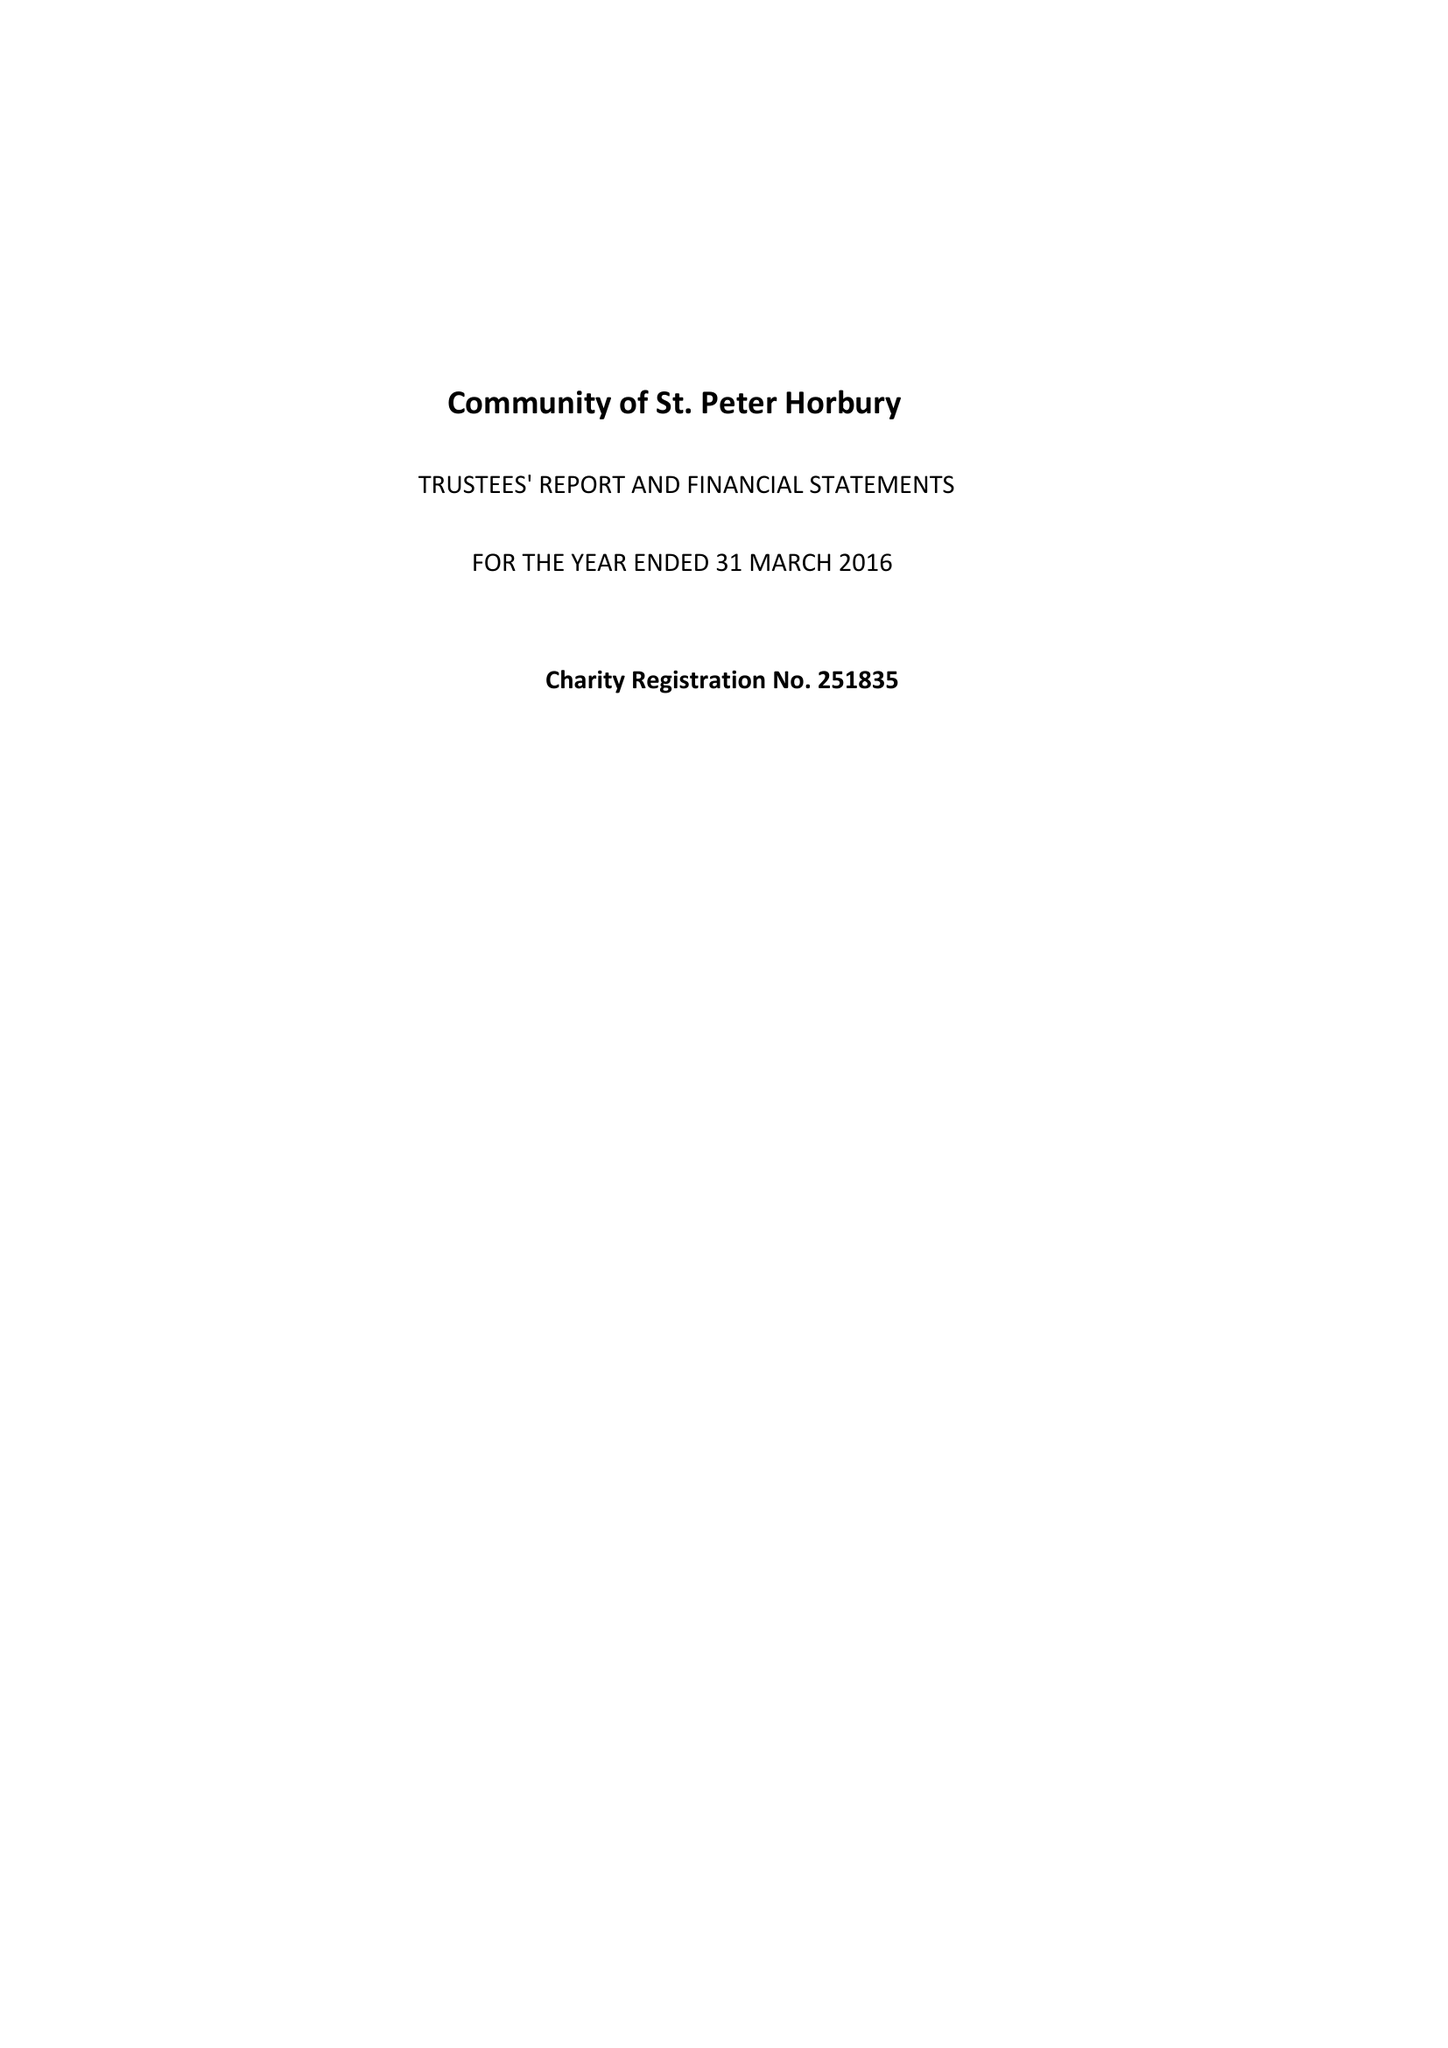What is the value for the address__postcode?
Answer the question using a single word or phrase. WF4 6DB 